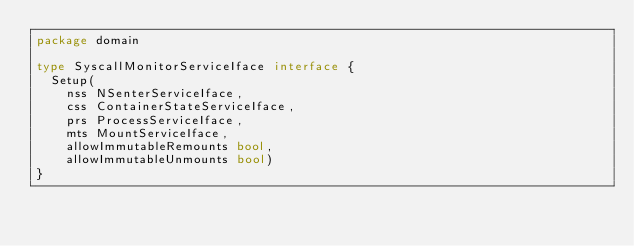<code> <loc_0><loc_0><loc_500><loc_500><_Go_>package domain

type SyscallMonitorServiceIface interface {
	Setup(
		nss NSenterServiceIface,
		css ContainerStateServiceIface,
		prs ProcessServiceIface,
		mts MountServiceIface,
		allowImmutableRemounts bool,
		allowImmutableUnmounts bool)
}
</code> 